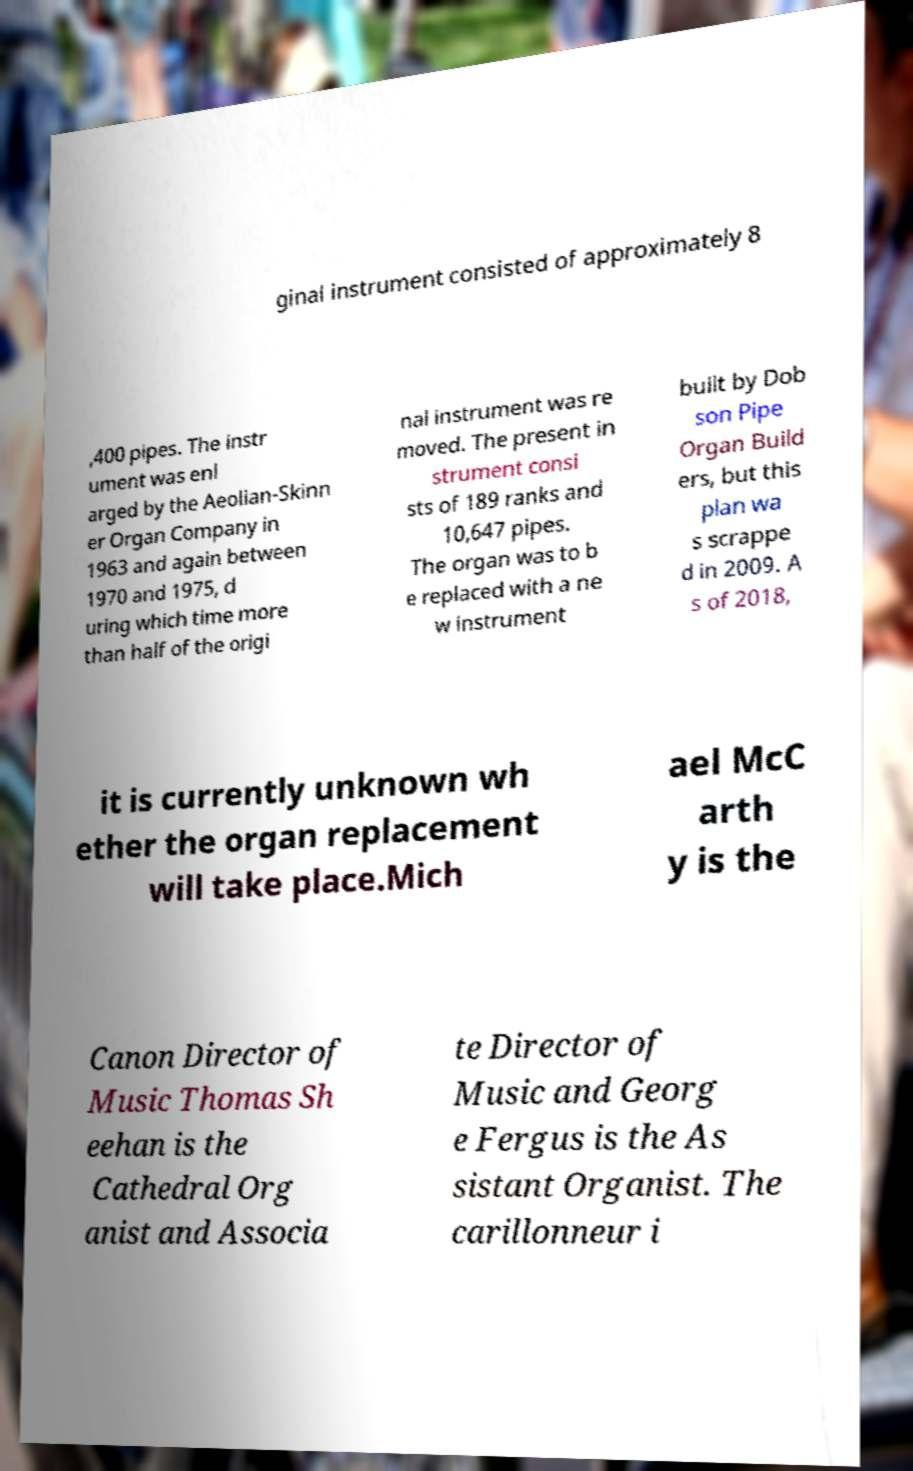Please identify and transcribe the text found in this image. ginal instrument consisted of approximately 8 ,400 pipes. The instr ument was enl arged by the Aeolian-Skinn er Organ Company in 1963 and again between 1970 and 1975, d uring which time more than half of the origi nal instrument was re moved. The present in strument consi sts of 189 ranks and 10,647 pipes. The organ was to b e replaced with a ne w instrument built by Dob son Pipe Organ Build ers, but this plan wa s scrappe d in 2009. A s of 2018, it is currently unknown wh ether the organ replacement will take place.Mich ael McC arth y is the Canon Director of Music Thomas Sh eehan is the Cathedral Org anist and Associa te Director of Music and Georg e Fergus is the As sistant Organist. The carillonneur i 